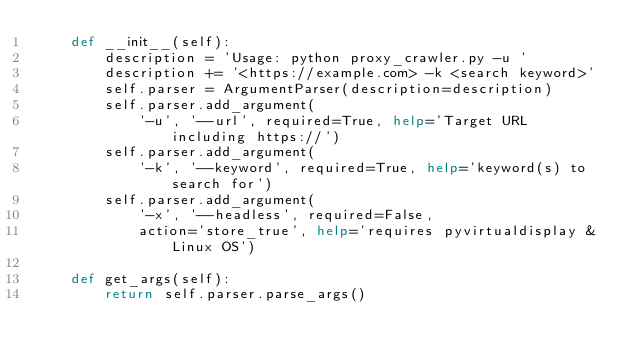<code> <loc_0><loc_0><loc_500><loc_500><_Python_>    def __init__(self):
        description = 'Usage: python proxy_crawler.py -u '
        description += '<https://example.com> -k <search keyword>'
        self.parser = ArgumentParser(description=description)
        self.parser.add_argument(
            '-u', '--url', required=True, help='Target URL including https://')
        self.parser.add_argument(
            '-k', '--keyword', required=True, help='keyword(s) to search for')
        self.parser.add_argument(
            '-x', '--headless', required=False,
            action='store_true', help='requires pyvirtualdisplay & Linux OS')

    def get_args(self):
        return self.parser.parse_args()
</code> 